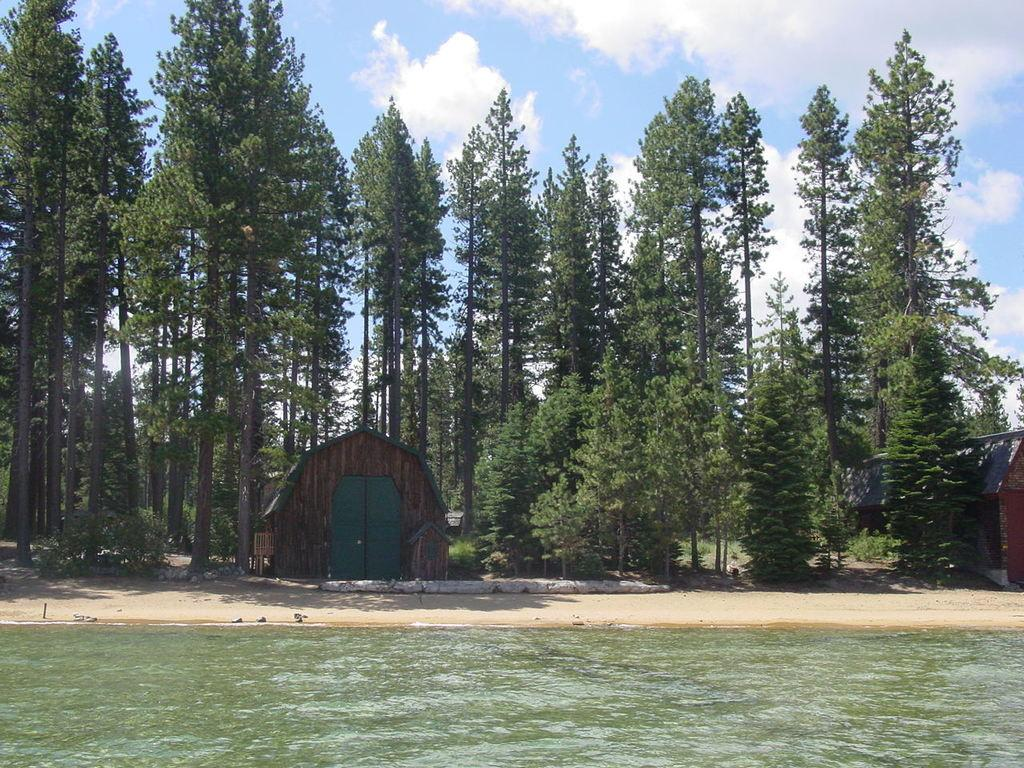What type of geographical feature can be seen in the image? There are watersheds in the image. What type of vegetation is present in the image? There are trees in the image. What else can be seen in the image besides watersheds and trees? There are objects in the image. What is visible in the background of the image? The sky is visible in the background of the image. What can be observed in the sky in the image? Clouds are present in the sky. What type of oven is visible in the image? There is no oven present in the image. How does the pollution affect the watersheds in the image? The image does not show any pollution, so its effect on the watersheds cannot be determined. 